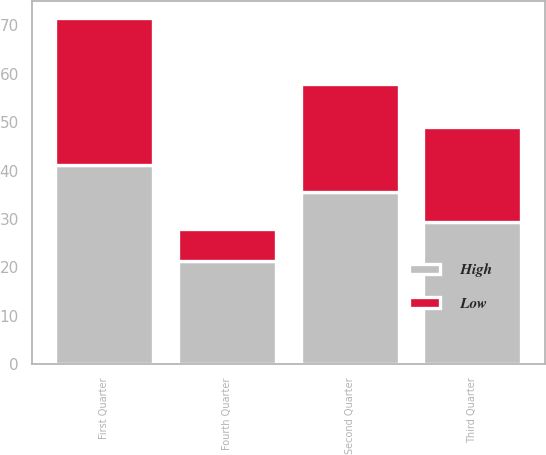<chart> <loc_0><loc_0><loc_500><loc_500><stacked_bar_chart><ecel><fcel>Fourth Quarter<fcel>Third Quarter<fcel>Second Quarter<fcel>First Quarter<nl><fcel>High<fcel>21.26<fcel>29.35<fcel>35.47<fcel>41.22<nl><fcel>Low<fcel>6.64<fcel>19.54<fcel>22.33<fcel>30.23<nl></chart> 